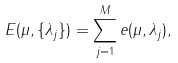Convert formula to latex. <formula><loc_0><loc_0><loc_500><loc_500>E ( \mu , \{ \lambda _ { j } \} ) = \sum _ { j = 1 } ^ { M } e ( \mu , \lambda _ { j } ) ,</formula> 